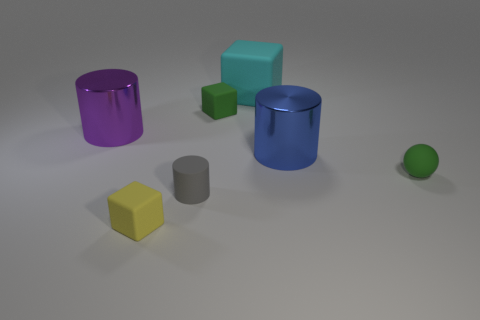There is a rubber thing that is the same size as the purple shiny cylinder; what is its color?
Your response must be concise. Cyan. Does the large purple object have the same shape as the big object that is right of the cyan object?
Keep it short and to the point. Yes. What is the material of the small thing that is behind the big metal thing that is left of the rubber thing in front of the small gray object?
Your response must be concise. Rubber. What number of tiny things are green rubber things or cyan rubber things?
Your answer should be very brief. 2. What number of other objects are there of the same size as the cyan rubber thing?
Give a very brief answer. 2. There is a tiny yellow object in front of the rubber cylinder; is it the same shape as the cyan rubber thing?
Make the answer very short. Yes. What color is the tiny rubber thing that is the same shape as the big purple metallic object?
Offer a terse response. Gray. Are there an equal number of large metallic cylinders on the left side of the tiny green matte cube and large gray cylinders?
Provide a succinct answer. No. How many things are both behind the small green sphere and on the right side of the small gray object?
Your answer should be very brief. 3. The blue metal thing that is the same shape as the gray thing is what size?
Your answer should be compact. Large. 